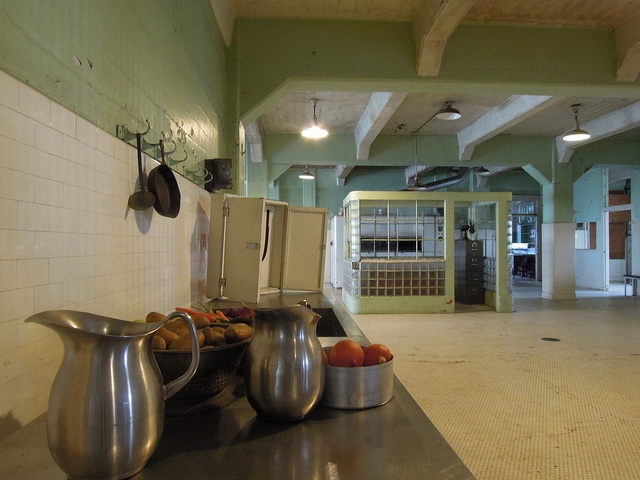Describe the objects in this image and their specific colors. I can see bowl in olive, gray, maroon, and black tones, bowl in olive, black, and gray tones, orange in olive, maroon, brown, and black tones, sink in olive, black, and gray tones, and orange in olive, maroon, and brown tones in this image. 